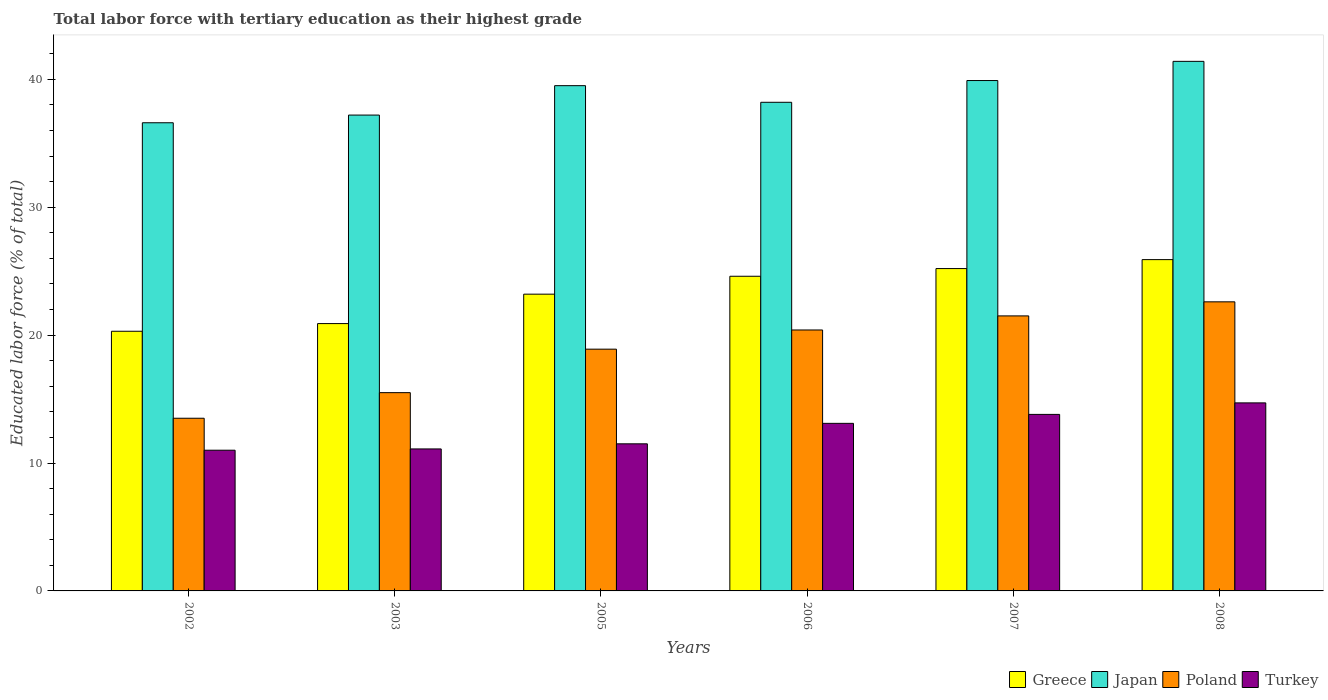How many different coloured bars are there?
Keep it short and to the point. 4. Are the number of bars on each tick of the X-axis equal?
Your answer should be compact. Yes. How many bars are there on the 3rd tick from the left?
Give a very brief answer. 4. How many bars are there on the 4th tick from the right?
Ensure brevity in your answer.  4. What is the label of the 3rd group of bars from the left?
Provide a short and direct response. 2005. What is the percentage of male labor force with tertiary education in Turkey in 2007?
Your response must be concise. 13.8. Across all years, what is the maximum percentage of male labor force with tertiary education in Japan?
Give a very brief answer. 41.4. Across all years, what is the minimum percentage of male labor force with tertiary education in Japan?
Offer a terse response. 36.6. In which year was the percentage of male labor force with tertiary education in Poland minimum?
Make the answer very short. 2002. What is the total percentage of male labor force with tertiary education in Japan in the graph?
Offer a terse response. 232.8. What is the difference between the percentage of male labor force with tertiary education in Poland in 2006 and that in 2007?
Give a very brief answer. -1.1. What is the difference between the percentage of male labor force with tertiary education in Greece in 2008 and the percentage of male labor force with tertiary education in Poland in 2005?
Make the answer very short. 7. What is the average percentage of male labor force with tertiary education in Japan per year?
Make the answer very short. 38.8. In the year 2002, what is the difference between the percentage of male labor force with tertiary education in Greece and percentage of male labor force with tertiary education in Poland?
Your response must be concise. 6.8. In how many years, is the percentage of male labor force with tertiary education in Poland greater than 36 %?
Offer a terse response. 0. What is the ratio of the percentage of male labor force with tertiary education in Greece in 2006 to that in 2007?
Provide a short and direct response. 0.98. What is the difference between the highest and the second highest percentage of male labor force with tertiary education in Turkey?
Your answer should be very brief. 0.9. What is the difference between the highest and the lowest percentage of male labor force with tertiary education in Poland?
Make the answer very short. 9.1. What does the 4th bar from the left in 2002 represents?
Provide a short and direct response. Turkey. What does the 1st bar from the right in 2008 represents?
Your answer should be very brief. Turkey. Is it the case that in every year, the sum of the percentage of male labor force with tertiary education in Poland and percentage of male labor force with tertiary education in Greece is greater than the percentage of male labor force with tertiary education in Japan?
Offer a terse response. No. How many years are there in the graph?
Your response must be concise. 6. Are the values on the major ticks of Y-axis written in scientific E-notation?
Provide a short and direct response. No. Where does the legend appear in the graph?
Provide a succinct answer. Bottom right. How many legend labels are there?
Your answer should be compact. 4. What is the title of the graph?
Provide a short and direct response. Total labor force with tertiary education as their highest grade. Does "Togo" appear as one of the legend labels in the graph?
Offer a terse response. No. What is the label or title of the X-axis?
Keep it short and to the point. Years. What is the label or title of the Y-axis?
Offer a terse response. Educated labor force (% of total). What is the Educated labor force (% of total) of Greece in 2002?
Offer a terse response. 20.3. What is the Educated labor force (% of total) of Japan in 2002?
Provide a succinct answer. 36.6. What is the Educated labor force (% of total) of Poland in 2002?
Make the answer very short. 13.5. What is the Educated labor force (% of total) in Turkey in 2002?
Keep it short and to the point. 11. What is the Educated labor force (% of total) in Greece in 2003?
Make the answer very short. 20.9. What is the Educated labor force (% of total) of Japan in 2003?
Your answer should be compact. 37.2. What is the Educated labor force (% of total) in Turkey in 2003?
Offer a very short reply. 11.1. What is the Educated labor force (% of total) of Greece in 2005?
Ensure brevity in your answer.  23.2. What is the Educated labor force (% of total) in Japan in 2005?
Give a very brief answer. 39.5. What is the Educated labor force (% of total) of Poland in 2005?
Provide a succinct answer. 18.9. What is the Educated labor force (% of total) of Turkey in 2005?
Make the answer very short. 11.5. What is the Educated labor force (% of total) in Greece in 2006?
Provide a short and direct response. 24.6. What is the Educated labor force (% of total) of Japan in 2006?
Your answer should be very brief. 38.2. What is the Educated labor force (% of total) of Poland in 2006?
Provide a succinct answer. 20.4. What is the Educated labor force (% of total) in Turkey in 2006?
Offer a very short reply. 13.1. What is the Educated labor force (% of total) of Greece in 2007?
Your response must be concise. 25.2. What is the Educated labor force (% of total) in Japan in 2007?
Make the answer very short. 39.9. What is the Educated labor force (% of total) of Turkey in 2007?
Ensure brevity in your answer.  13.8. What is the Educated labor force (% of total) of Greece in 2008?
Give a very brief answer. 25.9. What is the Educated labor force (% of total) of Japan in 2008?
Provide a short and direct response. 41.4. What is the Educated labor force (% of total) in Poland in 2008?
Give a very brief answer. 22.6. What is the Educated labor force (% of total) of Turkey in 2008?
Offer a very short reply. 14.7. Across all years, what is the maximum Educated labor force (% of total) of Greece?
Your answer should be very brief. 25.9. Across all years, what is the maximum Educated labor force (% of total) of Japan?
Provide a succinct answer. 41.4. Across all years, what is the maximum Educated labor force (% of total) in Poland?
Give a very brief answer. 22.6. Across all years, what is the maximum Educated labor force (% of total) in Turkey?
Your answer should be compact. 14.7. Across all years, what is the minimum Educated labor force (% of total) in Greece?
Offer a terse response. 20.3. Across all years, what is the minimum Educated labor force (% of total) of Japan?
Offer a very short reply. 36.6. What is the total Educated labor force (% of total) in Greece in the graph?
Your response must be concise. 140.1. What is the total Educated labor force (% of total) in Japan in the graph?
Offer a very short reply. 232.8. What is the total Educated labor force (% of total) of Poland in the graph?
Your response must be concise. 112.4. What is the total Educated labor force (% of total) in Turkey in the graph?
Keep it short and to the point. 75.2. What is the difference between the Educated labor force (% of total) in Greece in 2002 and that in 2003?
Provide a succinct answer. -0.6. What is the difference between the Educated labor force (% of total) of Turkey in 2002 and that in 2003?
Your answer should be compact. -0.1. What is the difference between the Educated labor force (% of total) in Poland in 2002 and that in 2005?
Offer a very short reply. -5.4. What is the difference between the Educated labor force (% of total) in Greece in 2002 and that in 2006?
Give a very brief answer. -4.3. What is the difference between the Educated labor force (% of total) of Greece in 2002 and that in 2007?
Make the answer very short. -4.9. What is the difference between the Educated labor force (% of total) of Japan in 2002 and that in 2007?
Your answer should be compact. -3.3. What is the difference between the Educated labor force (% of total) in Poland in 2002 and that in 2007?
Provide a succinct answer. -8. What is the difference between the Educated labor force (% of total) of Turkey in 2002 and that in 2007?
Your response must be concise. -2.8. What is the difference between the Educated labor force (% of total) of Poland in 2002 and that in 2008?
Ensure brevity in your answer.  -9.1. What is the difference between the Educated labor force (% of total) of Japan in 2003 and that in 2005?
Keep it short and to the point. -2.3. What is the difference between the Educated labor force (% of total) of Turkey in 2003 and that in 2005?
Your response must be concise. -0.4. What is the difference between the Educated labor force (% of total) of Japan in 2003 and that in 2006?
Ensure brevity in your answer.  -1. What is the difference between the Educated labor force (% of total) in Poland in 2003 and that in 2006?
Provide a short and direct response. -4.9. What is the difference between the Educated labor force (% of total) of Turkey in 2003 and that in 2006?
Provide a succinct answer. -2. What is the difference between the Educated labor force (% of total) of Greece in 2003 and that in 2007?
Give a very brief answer. -4.3. What is the difference between the Educated labor force (% of total) in Poland in 2003 and that in 2007?
Make the answer very short. -6. What is the difference between the Educated labor force (% of total) in Turkey in 2003 and that in 2007?
Offer a terse response. -2.7. What is the difference between the Educated labor force (% of total) in Greece in 2003 and that in 2008?
Make the answer very short. -5. What is the difference between the Educated labor force (% of total) in Japan in 2003 and that in 2008?
Offer a very short reply. -4.2. What is the difference between the Educated labor force (% of total) in Japan in 2005 and that in 2006?
Provide a succinct answer. 1.3. What is the difference between the Educated labor force (% of total) in Turkey in 2005 and that in 2006?
Your answer should be compact. -1.6. What is the difference between the Educated labor force (% of total) in Japan in 2005 and that in 2007?
Provide a short and direct response. -0.4. What is the difference between the Educated labor force (% of total) in Japan in 2005 and that in 2008?
Make the answer very short. -1.9. What is the difference between the Educated labor force (% of total) in Poland in 2005 and that in 2008?
Offer a terse response. -3.7. What is the difference between the Educated labor force (% of total) of Greece in 2006 and that in 2007?
Provide a short and direct response. -0.6. What is the difference between the Educated labor force (% of total) in Japan in 2006 and that in 2007?
Your answer should be very brief. -1.7. What is the difference between the Educated labor force (% of total) of Turkey in 2006 and that in 2007?
Provide a short and direct response. -0.7. What is the difference between the Educated labor force (% of total) of Greece in 2006 and that in 2008?
Keep it short and to the point. -1.3. What is the difference between the Educated labor force (% of total) in Turkey in 2006 and that in 2008?
Provide a succinct answer. -1.6. What is the difference between the Educated labor force (% of total) in Greece in 2007 and that in 2008?
Keep it short and to the point. -0.7. What is the difference between the Educated labor force (% of total) in Poland in 2007 and that in 2008?
Offer a terse response. -1.1. What is the difference between the Educated labor force (% of total) in Greece in 2002 and the Educated labor force (% of total) in Japan in 2003?
Your response must be concise. -16.9. What is the difference between the Educated labor force (% of total) of Greece in 2002 and the Educated labor force (% of total) of Poland in 2003?
Provide a short and direct response. 4.8. What is the difference between the Educated labor force (% of total) in Greece in 2002 and the Educated labor force (% of total) in Turkey in 2003?
Keep it short and to the point. 9.2. What is the difference between the Educated labor force (% of total) of Japan in 2002 and the Educated labor force (% of total) of Poland in 2003?
Provide a succinct answer. 21.1. What is the difference between the Educated labor force (% of total) of Japan in 2002 and the Educated labor force (% of total) of Turkey in 2003?
Your response must be concise. 25.5. What is the difference between the Educated labor force (% of total) in Poland in 2002 and the Educated labor force (% of total) in Turkey in 2003?
Provide a succinct answer. 2.4. What is the difference between the Educated labor force (% of total) of Greece in 2002 and the Educated labor force (% of total) of Japan in 2005?
Your answer should be very brief. -19.2. What is the difference between the Educated labor force (% of total) of Greece in 2002 and the Educated labor force (% of total) of Poland in 2005?
Ensure brevity in your answer.  1.4. What is the difference between the Educated labor force (% of total) of Greece in 2002 and the Educated labor force (% of total) of Turkey in 2005?
Make the answer very short. 8.8. What is the difference between the Educated labor force (% of total) of Japan in 2002 and the Educated labor force (% of total) of Turkey in 2005?
Your answer should be compact. 25.1. What is the difference between the Educated labor force (% of total) of Poland in 2002 and the Educated labor force (% of total) of Turkey in 2005?
Provide a succinct answer. 2. What is the difference between the Educated labor force (% of total) of Greece in 2002 and the Educated labor force (% of total) of Japan in 2006?
Your answer should be very brief. -17.9. What is the difference between the Educated labor force (% of total) of Poland in 2002 and the Educated labor force (% of total) of Turkey in 2006?
Give a very brief answer. 0.4. What is the difference between the Educated labor force (% of total) of Greece in 2002 and the Educated labor force (% of total) of Japan in 2007?
Provide a short and direct response. -19.6. What is the difference between the Educated labor force (% of total) of Japan in 2002 and the Educated labor force (% of total) of Turkey in 2007?
Give a very brief answer. 22.8. What is the difference between the Educated labor force (% of total) in Poland in 2002 and the Educated labor force (% of total) in Turkey in 2007?
Give a very brief answer. -0.3. What is the difference between the Educated labor force (% of total) of Greece in 2002 and the Educated labor force (% of total) of Japan in 2008?
Your answer should be very brief. -21.1. What is the difference between the Educated labor force (% of total) of Greece in 2002 and the Educated labor force (% of total) of Poland in 2008?
Keep it short and to the point. -2.3. What is the difference between the Educated labor force (% of total) of Greece in 2002 and the Educated labor force (% of total) of Turkey in 2008?
Offer a terse response. 5.6. What is the difference between the Educated labor force (% of total) of Japan in 2002 and the Educated labor force (% of total) of Poland in 2008?
Your response must be concise. 14. What is the difference between the Educated labor force (% of total) of Japan in 2002 and the Educated labor force (% of total) of Turkey in 2008?
Provide a short and direct response. 21.9. What is the difference between the Educated labor force (% of total) of Greece in 2003 and the Educated labor force (% of total) of Japan in 2005?
Provide a succinct answer. -18.6. What is the difference between the Educated labor force (% of total) of Greece in 2003 and the Educated labor force (% of total) of Poland in 2005?
Keep it short and to the point. 2. What is the difference between the Educated labor force (% of total) in Japan in 2003 and the Educated labor force (% of total) in Poland in 2005?
Offer a terse response. 18.3. What is the difference between the Educated labor force (% of total) in Japan in 2003 and the Educated labor force (% of total) in Turkey in 2005?
Your answer should be compact. 25.7. What is the difference between the Educated labor force (% of total) of Poland in 2003 and the Educated labor force (% of total) of Turkey in 2005?
Your answer should be very brief. 4. What is the difference between the Educated labor force (% of total) of Greece in 2003 and the Educated labor force (% of total) of Japan in 2006?
Your response must be concise. -17.3. What is the difference between the Educated labor force (% of total) of Japan in 2003 and the Educated labor force (% of total) of Poland in 2006?
Your response must be concise. 16.8. What is the difference between the Educated labor force (% of total) of Japan in 2003 and the Educated labor force (% of total) of Turkey in 2006?
Your response must be concise. 24.1. What is the difference between the Educated labor force (% of total) in Poland in 2003 and the Educated labor force (% of total) in Turkey in 2006?
Keep it short and to the point. 2.4. What is the difference between the Educated labor force (% of total) in Greece in 2003 and the Educated labor force (% of total) in Poland in 2007?
Ensure brevity in your answer.  -0.6. What is the difference between the Educated labor force (% of total) of Greece in 2003 and the Educated labor force (% of total) of Turkey in 2007?
Ensure brevity in your answer.  7.1. What is the difference between the Educated labor force (% of total) of Japan in 2003 and the Educated labor force (% of total) of Turkey in 2007?
Provide a short and direct response. 23.4. What is the difference between the Educated labor force (% of total) of Greece in 2003 and the Educated labor force (% of total) of Japan in 2008?
Your response must be concise. -20.5. What is the difference between the Educated labor force (% of total) of Greece in 2003 and the Educated labor force (% of total) of Turkey in 2008?
Keep it short and to the point. 6.2. What is the difference between the Educated labor force (% of total) of Japan in 2003 and the Educated labor force (% of total) of Poland in 2008?
Your response must be concise. 14.6. What is the difference between the Educated labor force (% of total) in Japan in 2005 and the Educated labor force (% of total) in Turkey in 2006?
Keep it short and to the point. 26.4. What is the difference between the Educated labor force (% of total) in Greece in 2005 and the Educated labor force (% of total) in Japan in 2007?
Give a very brief answer. -16.7. What is the difference between the Educated labor force (% of total) in Japan in 2005 and the Educated labor force (% of total) in Turkey in 2007?
Ensure brevity in your answer.  25.7. What is the difference between the Educated labor force (% of total) of Greece in 2005 and the Educated labor force (% of total) of Japan in 2008?
Make the answer very short. -18.2. What is the difference between the Educated labor force (% of total) of Greece in 2005 and the Educated labor force (% of total) of Poland in 2008?
Keep it short and to the point. 0.6. What is the difference between the Educated labor force (% of total) in Greece in 2005 and the Educated labor force (% of total) in Turkey in 2008?
Provide a succinct answer. 8.5. What is the difference between the Educated labor force (% of total) of Japan in 2005 and the Educated labor force (% of total) of Poland in 2008?
Ensure brevity in your answer.  16.9. What is the difference between the Educated labor force (% of total) in Japan in 2005 and the Educated labor force (% of total) in Turkey in 2008?
Your answer should be compact. 24.8. What is the difference between the Educated labor force (% of total) of Poland in 2005 and the Educated labor force (% of total) of Turkey in 2008?
Provide a succinct answer. 4.2. What is the difference between the Educated labor force (% of total) in Greece in 2006 and the Educated labor force (% of total) in Japan in 2007?
Your response must be concise. -15.3. What is the difference between the Educated labor force (% of total) in Greece in 2006 and the Educated labor force (% of total) in Poland in 2007?
Make the answer very short. 3.1. What is the difference between the Educated labor force (% of total) of Japan in 2006 and the Educated labor force (% of total) of Poland in 2007?
Offer a terse response. 16.7. What is the difference between the Educated labor force (% of total) in Japan in 2006 and the Educated labor force (% of total) in Turkey in 2007?
Provide a short and direct response. 24.4. What is the difference between the Educated labor force (% of total) of Poland in 2006 and the Educated labor force (% of total) of Turkey in 2007?
Make the answer very short. 6.6. What is the difference between the Educated labor force (% of total) in Greece in 2006 and the Educated labor force (% of total) in Japan in 2008?
Your answer should be compact. -16.8. What is the difference between the Educated labor force (% of total) of Greece in 2006 and the Educated labor force (% of total) of Poland in 2008?
Provide a short and direct response. 2. What is the difference between the Educated labor force (% of total) in Greece in 2006 and the Educated labor force (% of total) in Turkey in 2008?
Ensure brevity in your answer.  9.9. What is the difference between the Educated labor force (% of total) in Japan in 2006 and the Educated labor force (% of total) in Poland in 2008?
Your answer should be compact. 15.6. What is the difference between the Educated labor force (% of total) in Japan in 2006 and the Educated labor force (% of total) in Turkey in 2008?
Provide a succinct answer. 23.5. What is the difference between the Educated labor force (% of total) in Poland in 2006 and the Educated labor force (% of total) in Turkey in 2008?
Make the answer very short. 5.7. What is the difference between the Educated labor force (% of total) of Greece in 2007 and the Educated labor force (% of total) of Japan in 2008?
Make the answer very short. -16.2. What is the difference between the Educated labor force (% of total) of Japan in 2007 and the Educated labor force (% of total) of Poland in 2008?
Ensure brevity in your answer.  17.3. What is the difference between the Educated labor force (% of total) in Japan in 2007 and the Educated labor force (% of total) in Turkey in 2008?
Give a very brief answer. 25.2. What is the average Educated labor force (% of total) of Greece per year?
Your response must be concise. 23.35. What is the average Educated labor force (% of total) in Japan per year?
Offer a very short reply. 38.8. What is the average Educated labor force (% of total) in Poland per year?
Provide a short and direct response. 18.73. What is the average Educated labor force (% of total) of Turkey per year?
Your response must be concise. 12.53. In the year 2002, what is the difference between the Educated labor force (% of total) in Greece and Educated labor force (% of total) in Japan?
Your answer should be very brief. -16.3. In the year 2002, what is the difference between the Educated labor force (% of total) of Greece and Educated labor force (% of total) of Turkey?
Offer a terse response. 9.3. In the year 2002, what is the difference between the Educated labor force (% of total) in Japan and Educated labor force (% of total) in Poland?
Your response must be concise. 23.1. In the year 2002, what is the difference between the Educated labor force (% of total) in Japan and Educated labor force (% of total) in Turkey?
Provide a succinct answer. 25.6. In the year 2002, what is the difference between the Educated labor force (% of total) of Poland and Educated labor force (% of total) of Turkey?
Provide a succinct answer. 2.5. In the year 2003, what is the difference between the Educated labor force (% of total) in Greece and Educated labor force (% of total) in Japan?
Give a very brief answer. -16.3. In the year 2003, what is the difference between the Educated labor force (% of total) in Japan and Educated labor force (% of total) in Poland?
Offer a terse response. 21.7. In the year 2003, what is the difference between the Educated labor force (% of total) of Japan and Educated labor force (% of total) of Turkey?
Your answer should be compact. 26.1. In the year 2005, what is the difference between the Educated labor force (% of total) of Greece and Educated labor force (% of total) of Japan?
Offer a very short reply. -16.3. In the year 2005, what is the difference between the Educated labor force (% of total) of Greece and Educated labor force (% of total) of Poland?
Provide a succinct answer. 4.3. In the year 2005, what is the difference between the Educated labor force (% of total) of Greece and Educated labor force (% of total) of Turkey?
Provide a short and direct response. 11.7. In the year 2005, what is the difference between the Educated labor force (% of total) of Japan and Educated labor force (% of total) of Poland?
Provide a succinct answer. 20.6. In the year 2005, what is the difference between the Educated labor force (% of total) of Japan and Educated labor force (% of total) of Turkey?
Ensure brevity in your answer.  28. In the year 2006, what is the difference between the Educated labor force (% of total) in Greece and Educated labor force (% of total) in Japan?
Provide a succinct answer. -13.6. In the year 2006, what is the difference between the Educated labor force (% of total) of Greece and Educated labor force (% of total) of Poland?
Make the answer very short. 4.2. In the year 2006, what is the difference between the Educated labor force (% of total) in Japan and Educated labor force (% of total) in Poland?
Your response must be concise. 17.8. In the year 2006, what is the difference between the Educated labor force (% of total) of Japan and Educated labor force (% of total) of Turkey?
Provide a succinct answer. 25.1. In the year 2006, what is the difference between the Educated labor force (% of total) in Poland and Educated labor force (% of total) in Turkey?
Provide a short and direct response. 7.3. In the year 2007, what is the difference between the Educated labor force (% of total) of Greece and Educated labor force (% of total) of Japan?
Offer a very short reply. -14.7. In the year 2007, what is the difference between the Educated labor force (% of total) of Japan and Educated labor force (% of total) of Poland?
Your answer should be very brief. 18.4. In the year 2007, what is the difference between the Educated labor force (% of total) of Japan and Educated labor force (% of total) of Turkey?
Your answer should be very brief. 26.1. In the year 2007, what is the difference between the Educated labor force (% of total) in Poland and Educated labor force (% of total) in Turkey?
Provide a short and direct response. 7.7. In the year 2008, what is the difference between the Educated labor force (% of total) of Greece and Educated labor force (% of total) of Japan?
Ensure brevity in your answer.  -15.5. In the year 2008, what is the difference between the Educated labor force (% of total) of Greece and Educated labor force (% of total) of Turkey?
Give a very brief answer. 11.2. In the year 2008, what is the difference between the Educated labor force (% of total) in Japan and Educated labor force (% of total) in Poland?
Ensure brevity in your answer.  18.8. In the year 2008, what is the difference between the Educated labor force (% of total) of Japan and Educated labor force (% of total) of Turkey?
Give a very brief answer. 26.7. In the year 2008, what is the difference between the Educated labor force (% of total) of Poland and Educated labor force (% of total) of Turkey?
Keep it short and to the point. 7.9. What is the ratio of the Educated labor force (% of total) of Greece in 2002 to that in 2003?
Your answer should be very brief. 0.97. What is the ratio of the Educated labor force (% of total) of Japan in 2002 to that in 2003?
Give a very brief answer. 0.98. What is the ratio of the Educated labor force (% of total) of Poland in 2002 to that in 2003?
Make the answer very short. 0.87. What is the ratio of the Educated labor force (% of total) in Greece in 2002 to that in 2005?
Your answer should be very brief. 0.88. What is the ratio of the Educated labor force (% of total) in Japan in 2002 to that in 2005?
Provide a short and direct response. 0.93. What is the ratio of the Educated labor force (% of total) in Poland in 2002 to that in 2005?
Your answer should be compact. 0.71. What is the ratio of the Educated labor force (% of total) of Turkey in 2002 to that in 2005?
Your response must be concise. 0.96. What is the ratio of the Educated labor force (% of total) in Greece in 2002 to that in 2006?
Your answer should be very brief. 0.83. What is the ratio of the Educated labor force (% of total) in Japan in 2002 to that in 2006?
Provide a succinct answer. 0.96. What is the ratio of the Educated labor force (% of total) of Poland in 2002 to that in 2006?
Your answer should be very brief. 0.66. What is the ratio of the Educated labor force (% of total) of Turkey in 2002 to that in 2006?
Ensure brevity in your answer.  0.84. What is the ratio of the Educated labor force (% of total) in Greece in 2002 to that in 2007?
Ensure brevity in your answer.  0.81. What is the ratio of the Educated labor force (% of total) of Japan in 2002 to that in 2007?
Keep it short and to the point. 0.92. What is the ratio of the Educated labor force (% of total) of Poland in 2002 to that in 2007?
Offer a very short reply. 0.63. What is the ratio of the Educated labor force (% of total) in Turkey in 2002 to that in 2007?
Make the answer very short. 0.8. What is the ratio of the Educated labor force (% of total) in Greece in 2002 to that in 2008?
Offer a terse response. 0.78. What is the ratio of the Educated labor force (% of total) of Japan in 2002 to that in 2008?
Make the answer very short. 0.88. What is the ratio of the Educated labor force (% of total) in Poland in 2002 to that in 2008?
Your answer should be very brief. 0.6. What is the ratio of the Educated labor force (% of total) of Turkey in 2002 to that in 2008?
Your answer should be compact. 0.75. What is the ratio of the Educated labor force (% of total) in Greece in 2003 to that in 2005?
Make the answer very short. 0.9. What is the ratio of the Educated labor force (% of total) of Japan in 2003 to that in 2005?
Your answer should be compact. 0.94. What is the ratio of the Educated labor force (% of total) of Poland in 2003 to that in 2005?
Offer a very short reply. 0.82. What is the ratio of the Educated labor force (% of total) of Turkey in 2003 to that in 2005?
Your response must be concise. 0.97. What is the ratio of the Educated labor force (% of total) of Greece in 2003 to that in 2006?
Offer a terse response. 0.85. What is the ratio of the Educated labor force (% of total) of Japan in 2003 to that in 2006?
Offer a very short reply. 0.97. What is the ratio of the Educated labor force (% of total) in Poland in 2003 to that in 2006?
Your answer should be very brief. 0.76. What is the ratio of the Educated labor force (% of total) in Turkey in 2003 to that in 2006?
Offer a very short reply. 0.85. What is the ratio of the Educated labor force (% of total) of Greece in 2003 to that in 2007?
Offer a very short reply. 0.83. What is the ratio of the Educated labor force (% of total) in Japan in 2003 to that in 2007?
Offer a terse response. 0.93. What is the ratio of the Educated labor force (% of total) in Poland in 2003 to that in 2007?
Your answer should be very brief. 0.72. What is the ratio of the Educated labor force (% of total) of Turkey in 2003 to that in 2007?
Make the answer very short. 0.8. What is the ratio of the Educated labor force (% of total) in Greece in 2003 to that in 2008?
Your answer should be very brief. 0.81. What is the ratio of the Educated labor force (% of total) of Japan in 2003 to that in 2008?
Provide a succinct answer. 0.9. What is the ratio of the Educated labor force (% of total) in Poland in 2003 to that in 2008?
Your response must be concise. 0.69. What is the ratio of the Educated labor force (% of total) of Turkey in 2003 to that in 2008?
Your answer should be very brief. 0.76. What is the ratio of the Educated labor force (% of total) of Greece in 2005 to that in 2006?
Give a very brief answer. 0.94. What is the ratio of the Educated labor force (% of total) in Japan in 2005 to that in 2006?
Ensure brevity in your answer.  1.03. What is the ratio of the Educated labor force (% of total) in Poland in 2005 to that in 2006?
Make the answer very short. 0.93. What is the ratio of the Educated labor force (% of total) of Turkey in 2005 to that in 2006?
Your response must be concise. 0.88. What is the ratio of the Educated labor force (% of total) in Greece in 2005 to that in 2007?
Your answer should be compact. 0.92. What is the ratio of the Educated labor force (% of total) of Poland in 2005 to that in 2007?
Keep it short and to the point. 0.88. What is the ratio of the Educated labor force (% of total) in Turkey in 2005 to that in 2007?
Give a very brief answer. 0.83. What is the ratio of the Educated labor force (% of total) in Greece in 2005 to that in 2008?
Keep it short and to the point. 0.9. What is the ratio of the Educated labor force (% of total) of Japan in 2005 to that in 2008?
Your answer should be very brief. 0.95. What is the ratio of the Educated labor force (% of total) of Poland in 2005 to that in 2008?
Your response must be concise. 0.84. What is the ratio of the Educated labor force (% of total) of Turkey in 2005 to that in 2008?
Keep it short and to the point. 0.78. What is the ratio of the Educated labor force (% of total) in Greece in 2006 to that in 2007?
Offer a very short reply. 0.98. What is the ratio of the Educated labor force (% of total) in Japan in 2006 to that in 2007?
Keep it short and to the point. 0.96. What is the ratio of the Educated labor force (% of total) in Poland in 2006 to that in 2007?
Your response must be concise. 0.95. What is the ratio of the Educated labor force (% of total) of Turkey in 2006 to that in 2007?
Keep it short and to the point. 0.95. What is the ratio of the Educated labor force (% of total) in Greece in 2006 to that in 2008?
Provide a short and direct response. 0.95. What is the ratio of the Educated labor force (% of total) in Japan in 2006 to that in 2008?
Your answer should be compact. 0.92. What is the ratio of the Educated labor force (% of total) of Poland in 2006 to that in 2008?
Offer a terse response. 0.9. What is the ratio of the Educated labor force (% of total) in Turkey in 2006 to that in 2008?
Keep it short and to the point. 0.89. What is the ratio of the Educated labor force (% of total) of Greece in 2007 to that in 2008?
Provide a succinct answer. 0.97. What is the ratio of the Educated labor force (% of total) in Japan in 2007 to that in 2008?
Ensure brevity in your answer.  0.96. What is the ratio of the Educated labor force (% of total) of Poland in 2007 to that in 2008?
Your response must be concise. 0.95. What is the ratio of the Educated labor force (% of total) in Turkey in 2007 to that in 2008?
Offer a terse response. 0.94. What is the difference between the highest and the second highest Educated labor force (% of total) in Japan?
Make the answer very short. 1.5. What is the difference between the highest and the second highest Educated labor force (% of total) in Poland?
Your answer should be compact. 1.1. What is the difference between the highest and the second highest Educated labor force (% of total) in Turkey?
Keep it short and to the point. 0.9. What is the difference between the highest and the lowest Educated labor force (% of total) of Greece?
Ensure brevity in your answer.  5.6. What is the difference between the highest and the lowest Educated labor force (% of total) of Japan?
Offer a very short reply. 4.8. What is the difference between the highest and the lowest Educated labor force (% of total) in Turkey?
Offer a terse response. 3.7. 